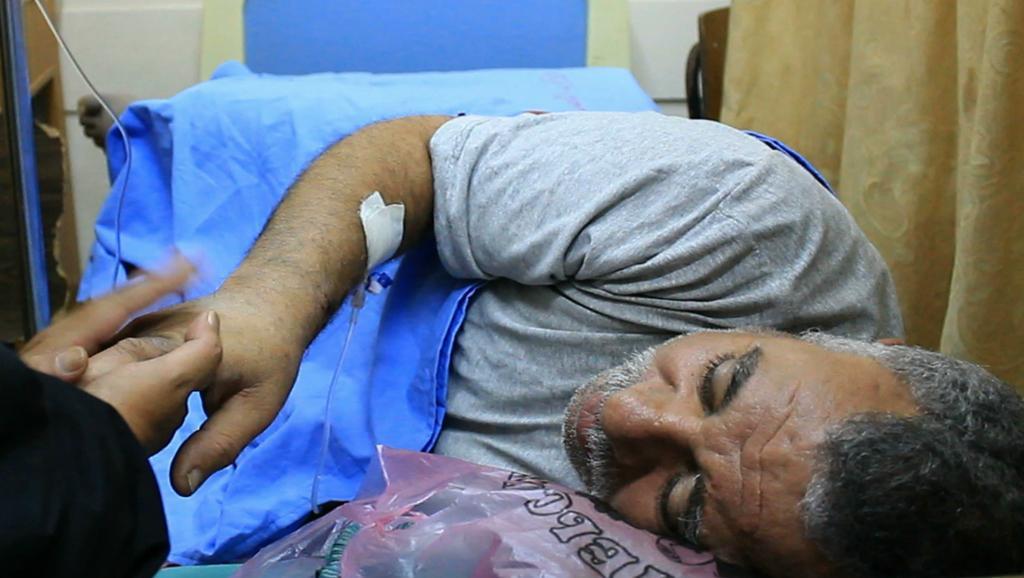Please provide a concise description of this image. Here in this picture we can see an old person laying and we can see a bed sheet on him and beside him we can see a curtain and another person is holding his hand and we can see a syringe pipe kept on his hand over there. 